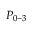<formula> <loc_0><loc_0><loc_500><loc_500>P _ { 0 - 3 }</formula> 